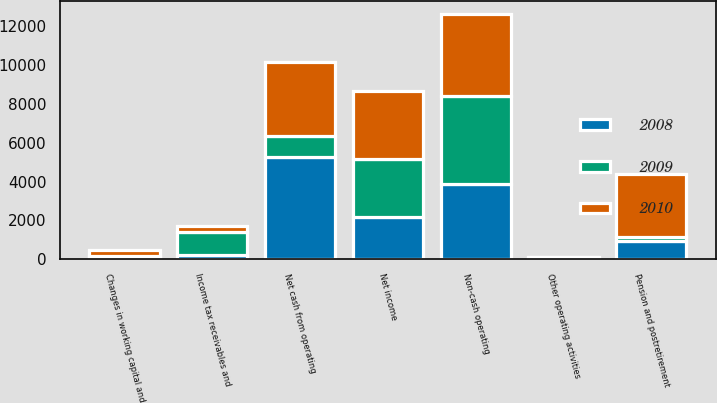Convert chart. <chart><loc_0><loc_0><loc_500><loc_500><stacked_bar_chart><ecel><fcel>Net income<fcel>Non-cash operating<fcel>Pension and postretirement<fcel>Income tax receivables and<fcel>Changes in working capital and<fcel>Other operating activities<fcel>Net cash from operating<nl><fcel>2010<fcel>3488<fcel>4248<fcel>3240<fcel>319<fcel>340<fcel>2<fcel>3835<nl><fcel>2008<fcel>2152<fcel>3863<fcel>924<fcel>245<fcel>137<fcel>86<fcel>5285<nl><fcel>2009<fcel>3003<fcel>4539<fcel>246<fcel>1167<fcel>6<fcel>31<fcel>1045.5<nl></chart> 